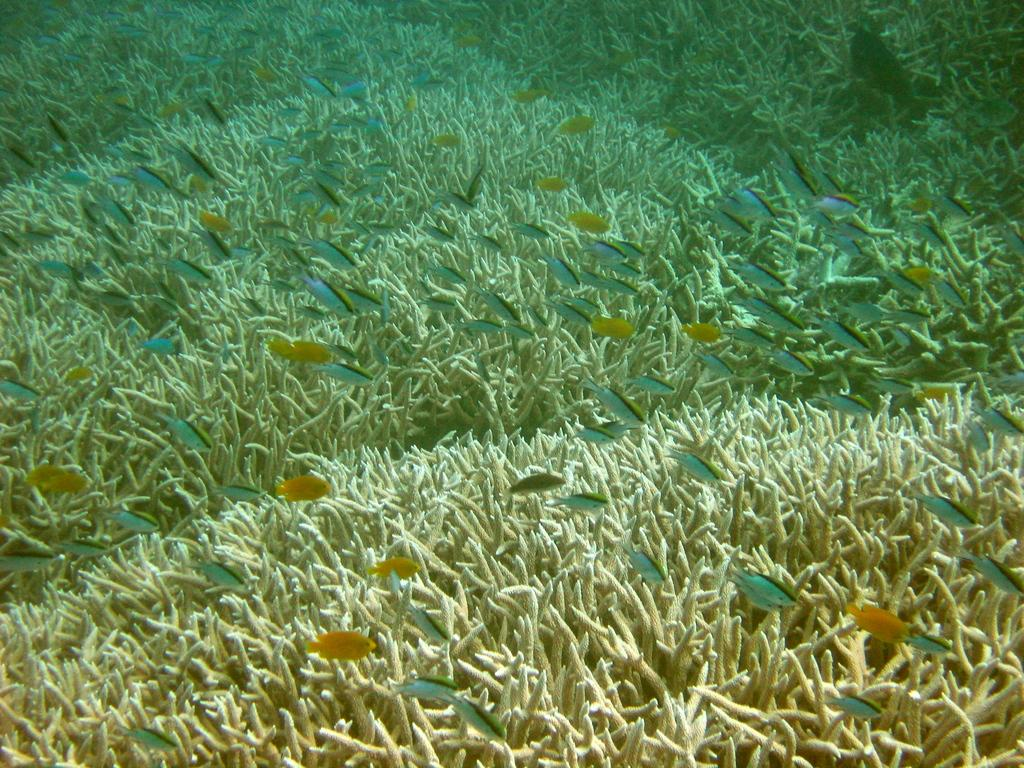What type of animals can be seen in the image? There are fishes in the image. What other living organisms are present in the image? There are aquatic plants in the image. Where are the fishes and aquatic plants located? The fishes and aquatic plants are underwater. What type of wound can be seen on the fish in the image? There is no wound visible on the fish in the image, as the fish appears to be healthy and swimming among the aquatic plants. 